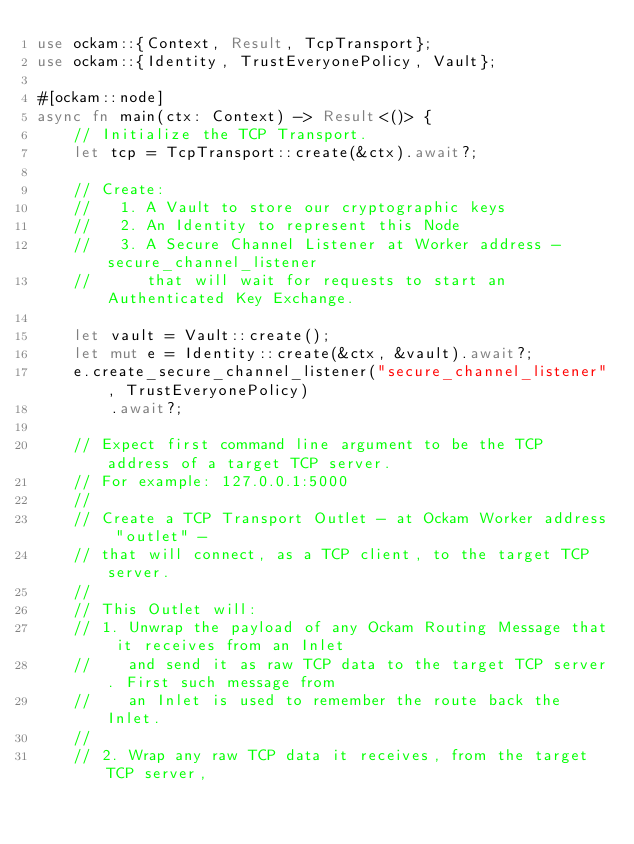<code> <loc_0><loc_0><loc_500><loc_500><_Rust_>use ockam::{Context, Result, TcpTransport};
use ockam::{Identity, TrustEveryonePolicy, Vault};

#[ockam::node]
async fn main(ctx: Context) -> Result<()> {
    // Initialize the TCP Transport.
    let tcp = TcpTransport::create(&ctx).await?;

    // Create:
    //   1. A Vault to store our cryptographic keys
    //   2. An Identity to represent this Node
    //   3. A Secure Channel Listener at Worker address - secure_channel_listener
    //      that will wait for requests to start an Authenticated Key Exchange.

    let vault = Vault::create();
    let mut e = Identity::create(&ctx, &vault).await?;
    e.create_secure_channel_listener("secure_channel_listener", TrustEveryonePolicy)
        .await?;

    // Expect first command line argument to be the TCP address of a target TCP server.
    // For example: 127.0.0.1:5000
    //
    // Create a TCP Transport Outlet - at Ockam Worker address "outlet" -
    // that will connect, as a TCP client, to the target TCP server.
    //
    // This Outlet will:
    // 1. Unwrap the payload of any Ockam Routing Message that it receives from an Inlet
    //    and send it as raw TCP data to the target TCP server. First such message from
    //    an Inlet is used to remember the route back the Inlet.
    //
    // 2. Wrap any raw TCP data it receives, from the target TCP server,</code> 